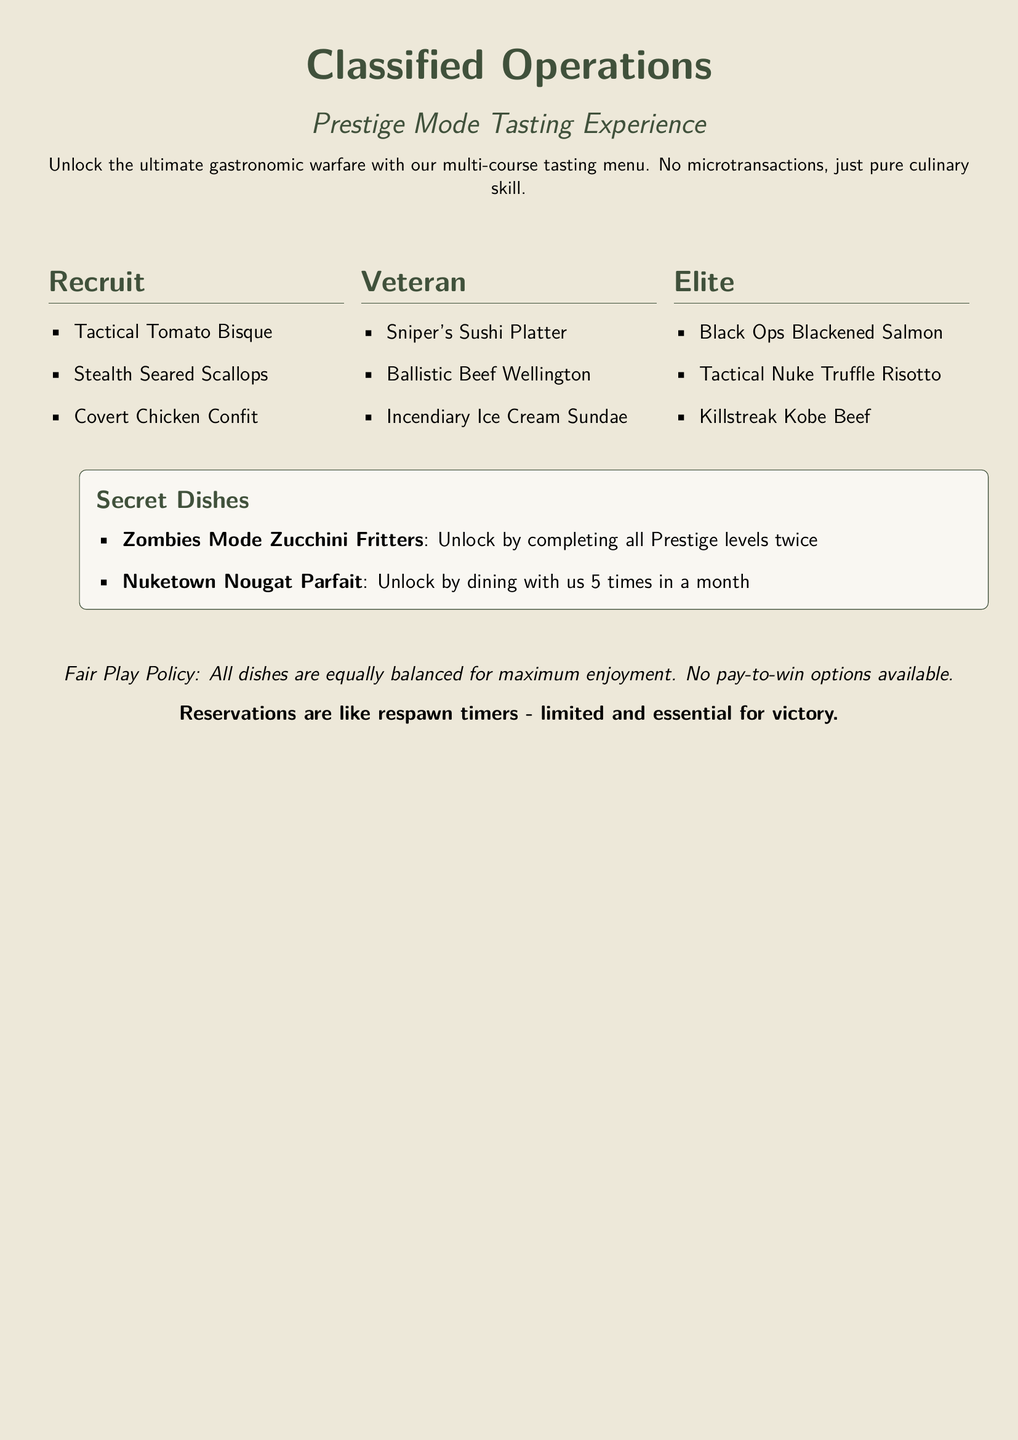What dishes are included in the Recruit section? The Recruit section lists three specific dishes: Tactical Tomato Bisque, Stealth Seared Scallops, and Covert Chicken Confit.
Answer: Tactical Tomato Bisque, Stealth Seared Scallops, Covert Chicken Confit How many courses are in the Elite section? The Elite section features a total of three unique dishes: Black Ops Blackened Salmon, Tactical Nuke Truffle Risotto, and Killstreak Kobe Beef.
Answer: 3 What must you do to unlock the Zombies Mode Zucchini Fritters? The secret dish Zombies Mode Zucchini Fritters has a requirement of completing all Prestige levels twice.
Answer: Completing all Prestige levels twice What is the name of the dessert in the Veteran section? The dessert listed in the Veteran section is Incendiary Ice Cream Sundae.
Answer: Incendiary Ice Cream Sundae How often do you need to dine to unlock Nuketown Nougat Parfait? The document states that you must dine with them 5 times in a month to unlock the dessert.
Answer: 5 times in a month What color is used for the headings in the menu? The headings are styled with a military color, defined in the document as military.
Answer: Military Are there any microtransaction options available in the menu? The document clearly states that there are no microtransaction options available, emphasizing fair play.
Answer: No What is the slogan regarding reservations? The slogan highlights the importance of reservations, comparing them to respawn timers in the context of gameplay.
Answer: Reservations are like respawn timers - limited and essential for victory 